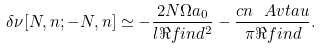<formula> <loc_0><loc_0><loc_500><loc_500>\delta \nu [ N , n ; - N , n ] \simeq - \frac { 2 N \Omega a _ { 0 } } { l \Re f i n d ^ { 2 } } - \frac { c n \ A v t a u } { \pi \Re f i n d } .</formula> 